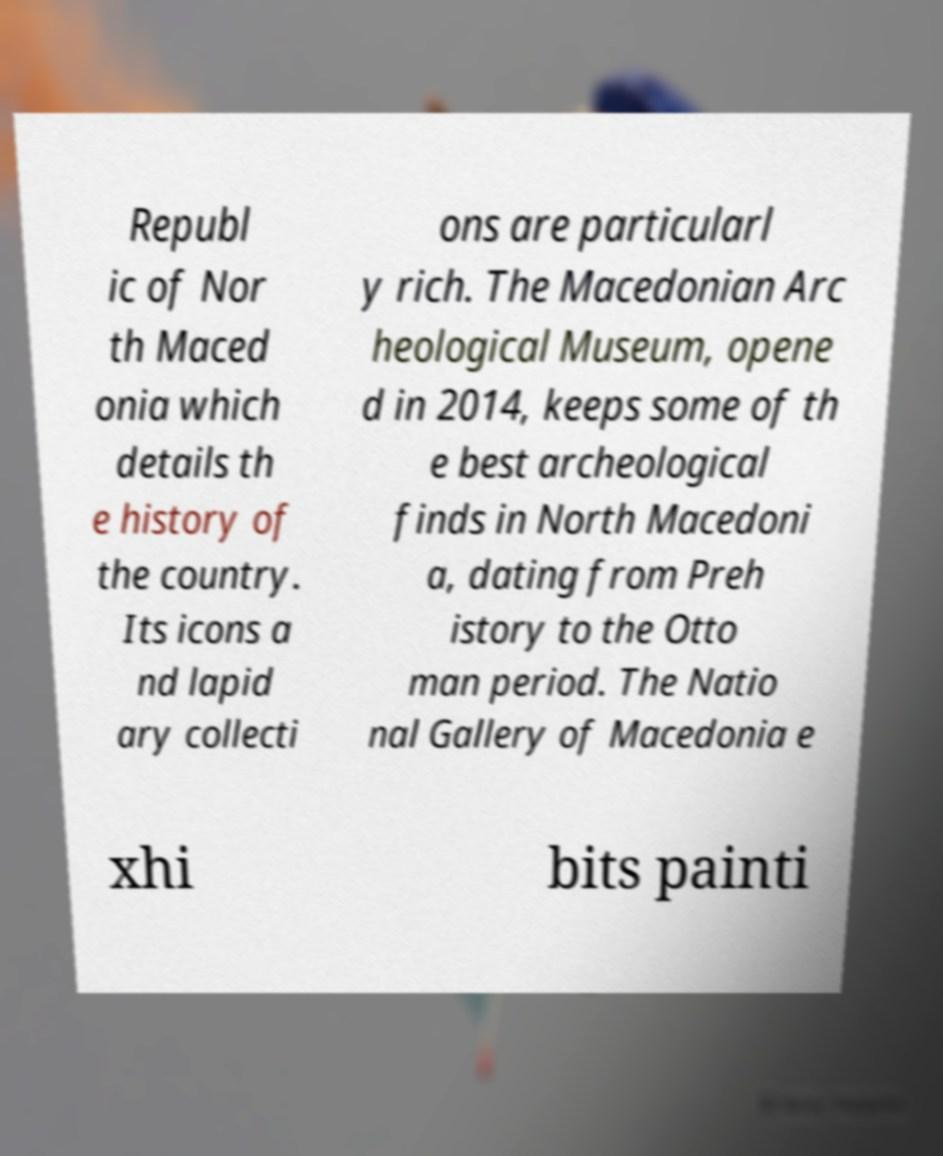There's text embedded in this image that I need extracted. Can you transcribe it verbatim? Republ ic of Nor th Maced onia which details th e history of the country. Its icons a nd lapid ary collecti ons are particularl y rich. The Macedonian Arc heological Museum, opene d in 2014, keeps some of th e best archeological finds in North Macedoni a, dating from Preh istory to the Otto man period. The Natio nal Gallery of Macedonia e xhi bits painti 